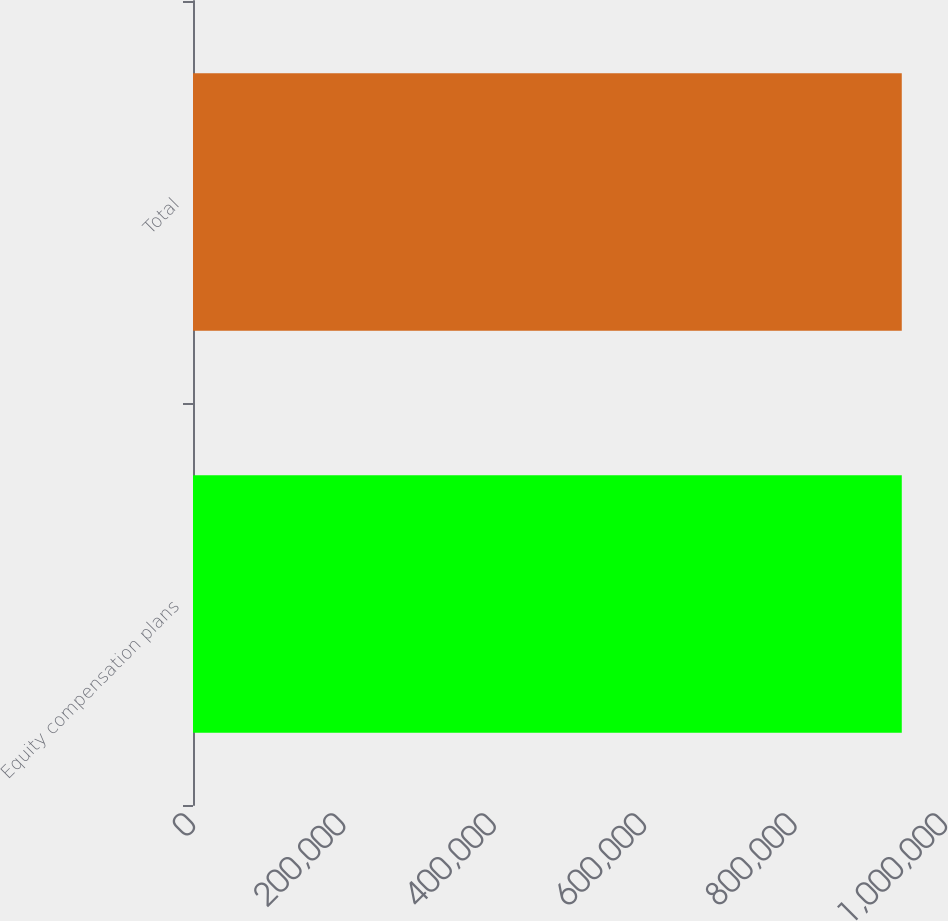Convert chart to OTSL. <chart><loc_0><loc_0><loc_500><loc_500><bar_chart><fcel>Equity compensation plans<fcel>Total<nl><fcel>942512<fcel>942512<nl></chart> 